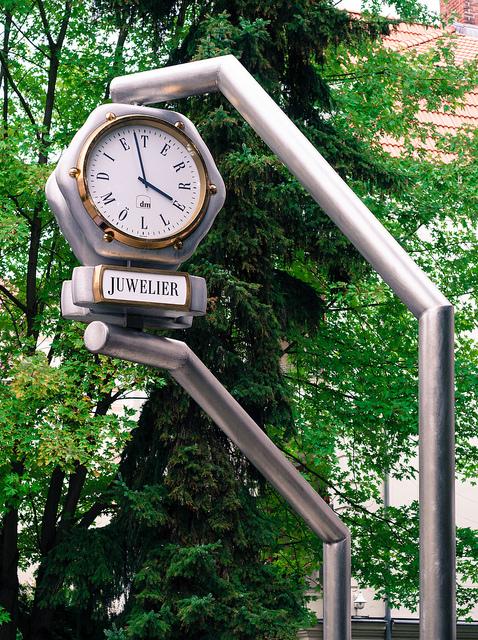Is this clock in English?
Write a very short answer. No. What time is it?
Quick response, please. 3:57. Are there numbers on the clock face?
Be succinct. No. 